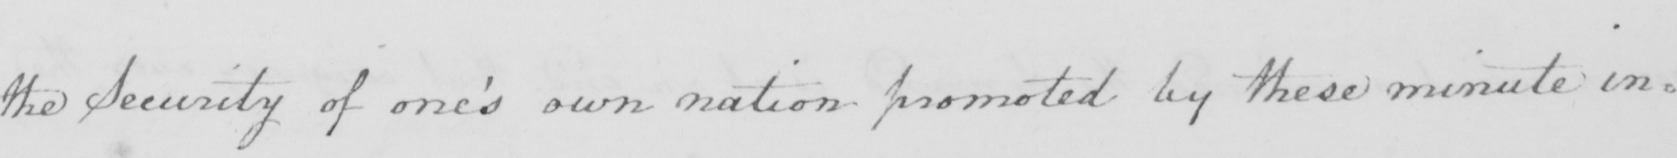Can you tell me what this handwritten text says? the Security of one ' s own nation promoted by these minute in= 